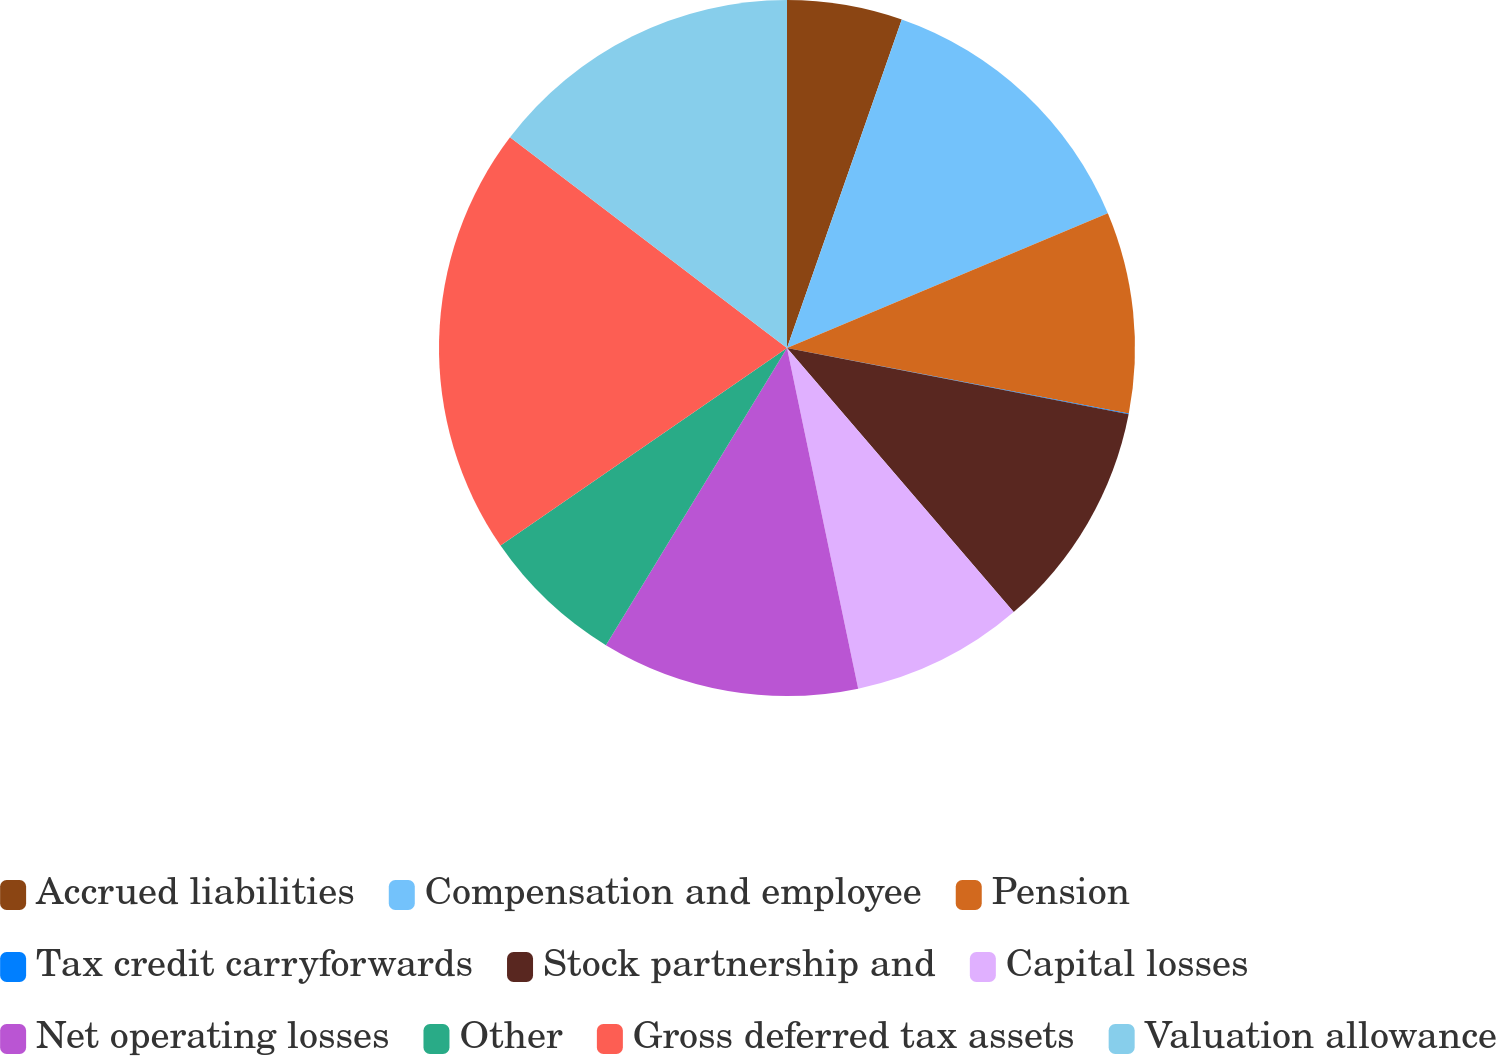Convert chart to OTSL. <chart><loc_0><loc_0><loc_500><loc_500><pie_chart><fcel>Accrued liabilities<fcel>Compensation and employee<fcel>Pension<fcel>Tax credit carryforwards<fcel>Stock partnership and<fcel>Capital losses<fcel>Net operating losses<fcel>Other<fcel>Gross deferred tax assets<fcel>Valuation allowance<nl><fcel>5.35%<fcel>13.32%<fcel>9.34%<fcel>0.04%<fcel>10.66%<fcel>8.01%<fcel>11.99%<fcel>6.68%<fcel>19.96%<fcel>14.65%<nl></chart> 